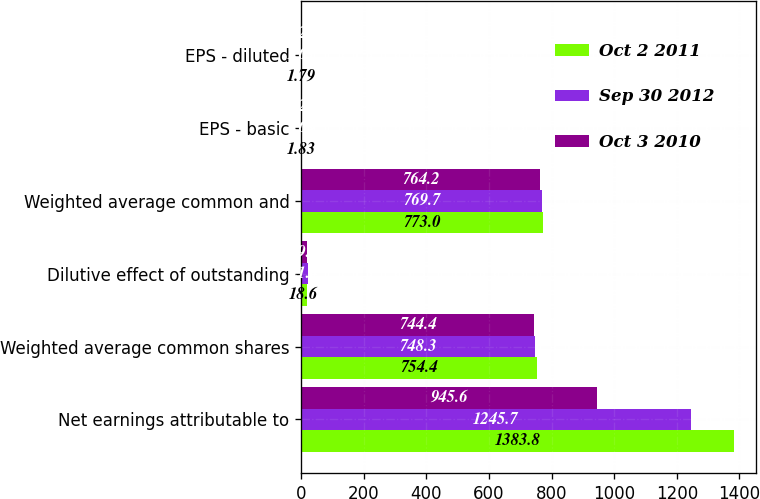<chart> <loc_0><loc_0><loc_500><loc_500><stacked_bar_chart><ecel><fcel>Net earnings attributable to<fcel>Weighted average common shares<fcel>Dilutive effect of outstanding<fcel>Weighted average common and<fcel>EPS - basic<fcel>EPS - diluted<nl><fcel>Oct 2 2011<fcel>1383.8<fcel>754.4<fcel>18.6<fcel>773<fcel>1.83<fcel>1.79<nl><fcel>Sep 30 2012<fcel>1245.7<fcel>748.3<fcel>21.4<fcel>769.7<fcel>1.66<fcel>1.62<nl><fcel>Oct 3 2010<fcel>945.6<fcel>744.4<fcel>19.8<fcel>764.2<fcel>1.27<fcel>1.24<nl></chart> 